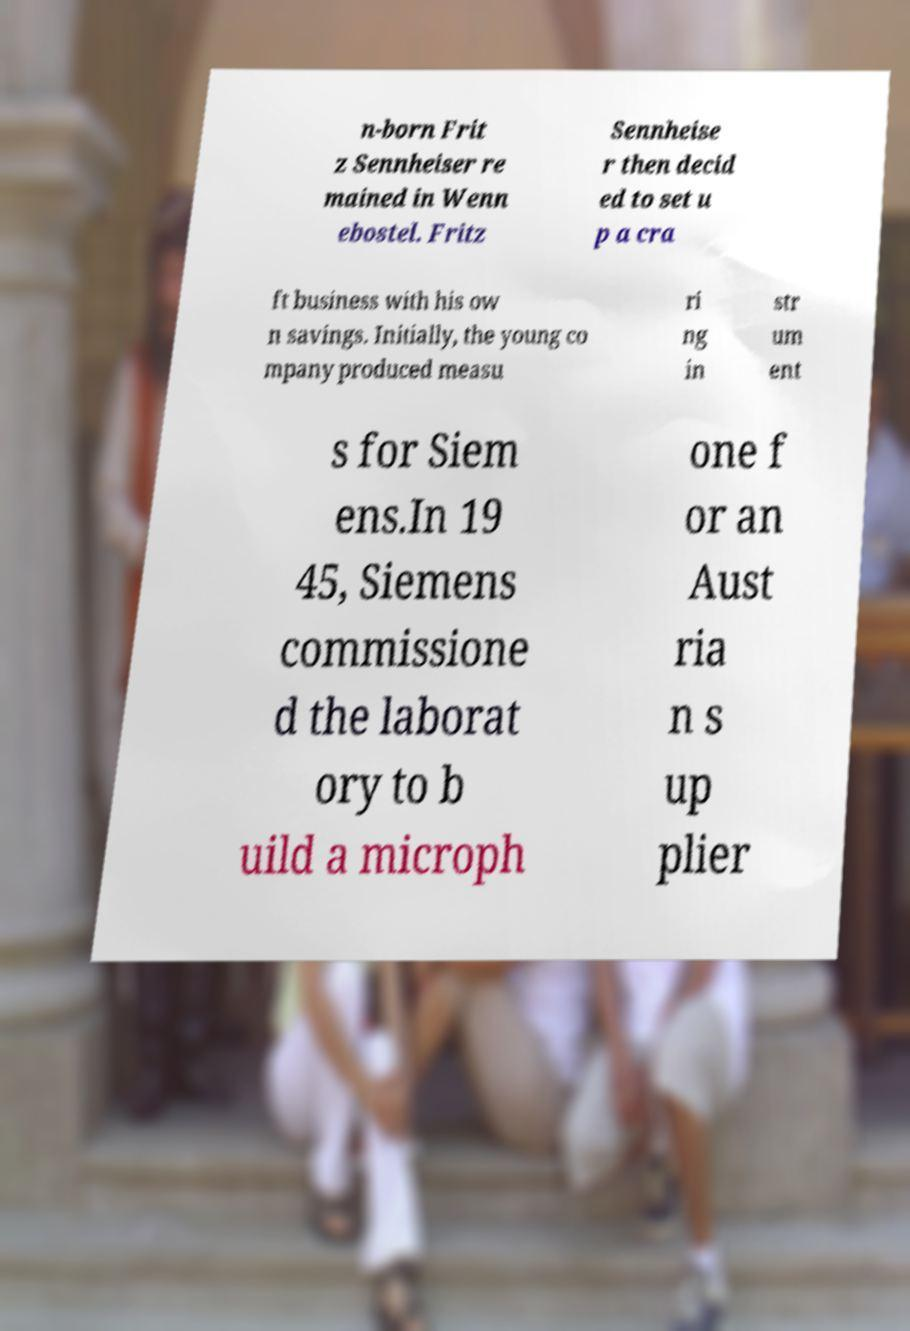Could you extract and type out the text from this image? n-born Frit z Sennheiser re mained in Wenn ebostel. Fritz Sennheise r then decid ed to set u p a cra ft business with his ow n savings. Initially, the young co mpany produced measu ri ng in str um ent s for Siem ens.In 19 45, Siemens commissione d the laborat ory to b uild a microph one f or an Aust ria n s up plier 